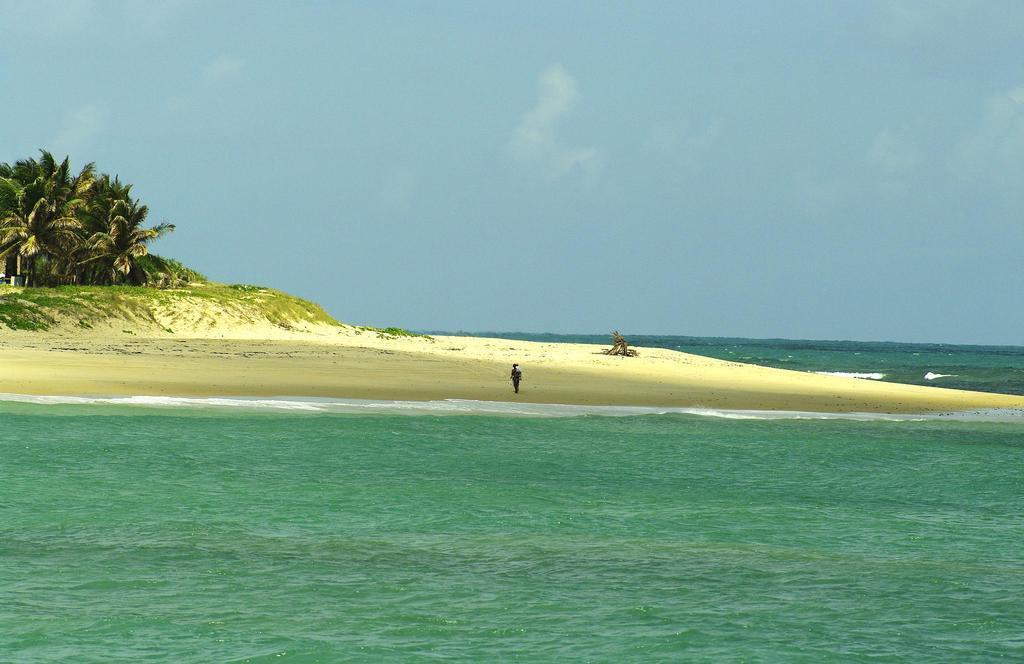Could you give a brief overview of what you see in this image? In this image we can see water, sand, grass, trees, and a person. In the background there is sky. 